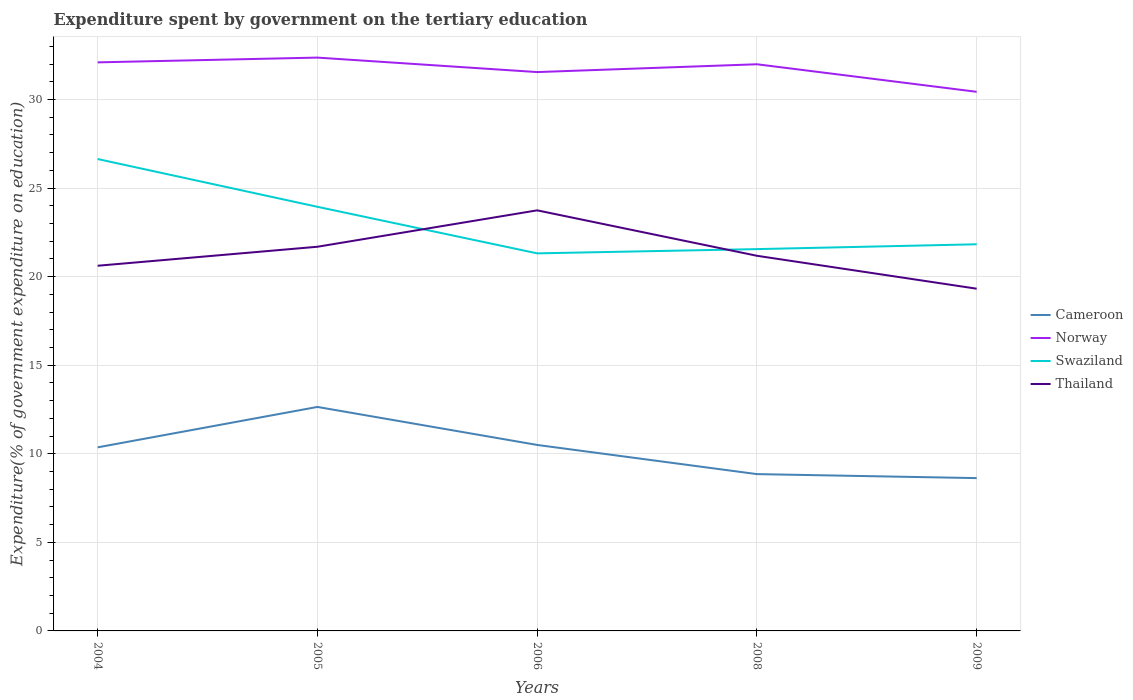Across all years, what is the maximum expenditure spent by government on the tertiary education in Norway?
Provide a succinct answer. 30.43. What is the total expenditure spent by government on the tertiary education in Cameroon in the graph?
Your answer should be compact. 3.79. What is the difference between the highest and the second highest expenditure spent by government on the tertiary education in Norway?
Offer a terse response. 1.93. What is the difference between the highest and the lowest expenditure spent by government on the tertiary education in Swaziland?
Keep it short and to the point. 2. How many lines are there?
Your answer should be very brief. 4. How many years are there in the graph?
Your answer should be very brief. 5. What is the difference between two consecutive major ticks on the Y-axis?
Your answer should be compact. 5. Are the values on the major ticks of Y-axis written in scientific E-notation?
Make the answer very short. No. How are the legend labels stacked?
Ensure brevity in your answer.  Vertical. What is the title of the graph?
Ensure brevity in your answer.  Expenditure spent by government on the tertiary education. What is the label or title of the Y-axis?
Provide a succinct answer. Expenditure(% of government expenditure on education). What is the Expenditure(% of government expenditure on education) in Cameroon in 2004?
Your response must be concise. 10.36. What is the Expenditure(% of government expenditure on education) in Norway in 2004?
Provide a short and direct response. 32.09. What is the Expenditure(% of government expenditure on education) in Swaziland in 2004?
Offer a terse response. 26.64. What is the Expenditure(% of government expenditure on education) of Thailand in 2004?
Make the answer very short. 20.61. What is the Expenditure(% of government expenditure on education) in Cameroon in 2005?
Make the answer very short. 12.64. What is the Expenditure(% of government expenditure on education) in Norway in 2005?
Your answer should be very brief. 32.36. What is the Expenditure(% of government expenditure on education) in Swaziland in 2005?
Provide a short and direct response. 23.94. What is the Expenditure(% of government expenditure on education) in Thailand in 2005?
Provide a succinct answer. 21.69. What is the Expenditure(% of government expenditure on education) in Cameroon in 2006?
Your answer should be very brief. 10.5. What is the Expenditure(% of government expenditure on education) of Norway in 2006?
Ensure brevity in your answer.  31.55. What is the Expenditure(% of government expenditure on education) of Swaziland in 2006?
Keep it short and to the point. 21.31. What is the Expenditure(% of government expenditure on education) in Thailand in 2006?
Your answer should be very brief. 23.74. What is the Expenditure(% of government expenditure on education) in Cameroon in 2008?
Provide a short and direct response. 8.85. What is the Expenditure(% of government expenditure on education) in Norway in 2008?
Provide a succinct answer. 31.99. What is the Expenditure(% of government expenditure on education) in Swaziland in 2008?
Your answer should be very brief. 21.55. What is the Expenditure(% of government expenditure on education) in Thailand in 2008?
Your response must be concise. 21.18. What is the Expenditure(% of government expenditure on education) in Cameroon in 2009?
Offer a terse response. 8.63. What is the Expenditure(% of government expenditure on education) in Norway in 2009?
Your answer should be compact. 30.43. What is the Expenditure(% of government expenditure on education) in Swaziland in 2009?
Offer a very short reply. 21.82. What is the Expenditure(% of government expenditure on education) in Thailand in 2009?
Give a very brief answer. 19.32. Across all years, what is the maximum Expenditure(% of government expenditure on education) of Cameroon?
Your answer should be compact. 12.64. Across all years, what is the maximum Expenditure(% of government expenditure on education) in Norway?
Your answer should be very brief. 32.36. Across all years, what is the maximum Expenditure(% of government expenditure on education) of Swaziland?
Your answer should be very brief. 26.64. Across all years, what is the maximum Expenditure(% of government expenditure on education) of Thailand?
Offer a very short reply. 23.74. Across all years, what is the minimum Expenditure(% of government expenditure on education) of Cameroon?
Give a very brief answer. 8.63. Across all years, what is the minimum Expenditure(% of government expenditure on education) in Norway?
Your answer should be very brief. 30.43. Across all years, what is the minimum Expenditure(% of government expenditure on education) of Swaziland?
Your answer should be very brief. 21.31. Across all years, what is the minimum Expenditure(% of government expenditure on education) of Thailand?
Your answer should be compact. 19.32. What is the total Expenditure(% of government expenditure on education) in Cameroon in the graph?
Your answer should be very brief. 50.98. What is the total Expenditure(% of government expenditure on education) in Norway in the graph?
Offer a terse response. 158.42. What is the total Expenditure(% of government expenditure on education) of Swaziland in the graph?
Your response must be concise. 115.27. What is the total Expenditure(% of government expenditure on education) in Thailand in the graph?
Provide a succinct answer. 106.53. What is the difference between the Expenditure(% of government expenditure on education) of Cameroon in 2004 and that in 2005?
Give a very brief answer. -2.28. What is the difference between the Expenditure(% of government expenditure on education) of Norway in 2004 and that in 2005?
Give a very brief answer. -0.27. What is the difference between the Expenditure(% of government expenditure on education) of Swaziland in 2004 and that in 2005?
Give a very brief answer. 2.7. What is the difference between the Expenditure(% of government expenditure on education) of Thailand in 2004 and that in 2005?
Provide a succinct answer. -1.07. What is the difference between the Expenditure(% of government expenditure on education) in Cameroon in 2004 and that in 2006?
Your answer should be very brief. -0.14. What is the difference between the Expenditure(% of government expenditure on education) in Norway in 2004 and that in 2006?
Provide a short and direct response. 0.55. What is the difference between the Expenditure(% of government expenditure on education) in Swaziland in 2004 and that in 2006?
Your response must be concise. 5.32. What is the difference between the Expenditure(% of government expenditure on education) of Thailand in 2004 and that in 2006?
Offer a terse response. -3.13. What is the difference between the Expenditure(% of government expenditure on education) of Cameroon in 2004 and that in 2008?
Give a very brief answer. 1.51. What is the difference between the Expenditure(% of government expenditure on education) of Norway in 2004 and that in 2008?
Keep it short and to the point. 0.11. What is the difference between the Expenditure(% of government expenditure on education) of Swaziland in 2004 and that in 2008?
Make the answer very short. 5.08. What is the difference between the Expenditure(% of government expenditure on education) in Thailand in 2004 and that in 2008?
Provide a succinct answer. -0.56. What is the difference between the Expenditure(% of government expenditure on education) of Cameroon in 2004 and that in 2009?
Provide a short and direct response. 1.74. What is the difference between the Expenditure(% of government expenditure on education) in Norway in 2004 and that in 2009?
Your response must be concise. 1.66. What is the difference between the Expenditure(% of government expenditure on education) in Swaziland in 2004 and that in 2009?
Offer a very short reply. 4.81. What is the difference between the Expenditure(% of government expenditure on education) of Thailand in 2004 and that in 2009?
Offer a terse response. 1.29. What is the difference between the Expenditure(% of government expenditure on education) of Cameroon in 2005 and that in 2006?
Offer a very short reply. 2.15. What is the difference between the Expenditure(% of government expenditure on education) of Norway in 2005 and that in 2006?
Your answer should be compact. 0.82. What is the difference between the Expenditure(% of government expenditure on education) in Swaziland in 2005 and that in 2006?
Make the answer very short. 2.63. What is the difference between the Expenditure(% of government expenditure on education) in Thailand in 2005 and that in 2006?
Ensure brevity in your answer.  -2.06. What is the difference between the Expenditure(% of government expenditure on education) in Cameroon in 2005 and that in 2008?
Give a very brief answer. 3.79. What is the difference between the Expenditure(% of government expenditure on education) in Norway in 2005 and that in 2008?
Give a very brief answer. 0.38. What is the difference between the Expenditure(% of government expenditure on education) of Swaziland in 2005 and that in 2008?
Offer a very short reply. 2.39. What is the difference between the Expenditure(% of government expenditure on education) of Thailand in 2005 and that in 2008?
Your answer should be very brief. 0.51. What is the difference between the Expenditure(% of government expenditure on education) of Cameroon in 2005 and that in 2009?
Your answer should be very brief. 4.02. What is the difference between the Expenditure(% of government expenditure on education) of Norway in 2005 and that in 2009?
Ensure brevity in your answer.  1.93. What is the difference between the Expenditure(% of government expenditure on education) of Swaziland in 2005 and that in 2009?
Keep it short and to the point. 2.12. What is the difference between the Expenditure(% of government expenditure on education) in Thailand in 2005 and that in 2009?
Give a very brief answer. 2.37. What is the difference between the Expenditure(% of government expenditure on education) of Cameroon in 2006 and that in 2008?
Keep it short and to the point. 1.65. What is the difference between the Expenditure(% of government expenditure on education) in Norway in 2006 and that in 2008?
Ensure brevity in your answer.  -0.44. What is the difference between the Expenditure(% of government expenditure on education) of Swaziland in 2006 and that in 2008?
Ensure brevity in your answer.  -0.24. What is the difference between the Expenditure(% of government expenditure on education) in Thailand in 2006 and that in 2008?
Your response must be concise. 2.56. What is the difference between the Expenditure(% of government expenditure on education) in Cameroon in 2006 and that in 2009?
Keep it short and to the point. 1.87. What is the difference between the Expenditure(% of government expenditure on education) in Norway in 2006 and that in 2009?
Offer a very short reply. 1.11. What is the difference between the Expenditure(% of government expenditure on education) in Swaziland in 2006 and that in 2009?
Keep it short and to the point. -0.51. What is the difference between the Expenditure(% of government expenditure on education) in Thailand in 2006 and that in 2009?
Ensure brevity in your answer.  4.42. What is the difference between the Expenditure(% of government expenditure on education) in Cameroon in 2008 and that in 2009?
Make the answer very short. 0.23. What is the difference between the Expenditure(% of government expenditure on education) of Norway in 2008 and that in 2009?
Your response must be concise. 1.56. What is the difference between the Expenditure(% of government expenditure on education) in Swaziland in 2008 and that in 2009?
Keep it short and to the point. -0.27. What is the difference between the Expenditure(% of government expenditure on education) in Thailand in 2008 and that in 2009?
Offer a terse response. 1.86. What is the difference between the Expenditure(% of government expenditure on education) in Cameroon in 2004 and the Expenditure(% of government expenditure on education) in Norway in 2005?
Offer a terse response. -22. What is the difference between the Expenditure(% of government expenditure on education) of Cameroon in 2004 and the Expenditure(% of government expenditure on education) of Swaziland in 2005?
Provide a succinct answer. -13.58. What is the difference between the Expenditure(% of government expenditure on education) in Cameroon in 2004 and the Expenditure(% of government expenditure on education) in Thailand in 2005?
Offer a terse response. -11.32. What is the difference between the Expenditure(% of government expenditure on education) of Norway in 2004 and the Expenditure(% of government expenditure on education) of Swaziland in 2005?
Provide a succinct answer. 8.15. What is the difference between the Expenditure(% of government expenditure on education) of Norway in 2004 and the Expenditure(% of government expenditure on education) of Thailand in 2005?
Your response must be concise. 10.41. What is the difference between the Expenditure(% of government expenditure on education) of Swaziland in 2004 and the Expenditure(% of government expenditure on education) of Thailand in 2005?
Make the answer very short. 4.95. What is the difference between the Expenditure(% of government expenditure on education) in Cameroon in 2004 and the Expenditure(% of government expenditure on education) in Norway in 2006?
Provide a succinct answer. -21.18. What is the difference between the Expenditure(% of government expenditure on education) of Cameroon in 2004 and the Expenditure(% of government expenditure on education) of Swaziland in 2006?
Ensure brevity in your answer.  -10.95. What is the difference between the Expenditure(% of government expenditure on education) in Cameroon in 2004 and the Expenditure(% of government expenditure on education) in Thailand in 2006?
Make the answer very short. -13.38. What is the difference between the Expenditure(% of government expenditure on education) of Norway in 2004 and the Expenditure(% of government expenditure on education) of Swaziland in 2006?
Make the answer very short. 10.78. What is the difference between the Expenditure(% of government expenditure on education) of Norway in 2004 and the Expenditure(% of government expenditure on education) of Thailand in 2006?
Make the answer very short. 8.35. What is the difference between the Expenditure(% of government expenditure on education) of Swaziland in 2004 and the Expenditure(% of government expenditure on education) of Thailand in 2006?
Provide a succinct answer. 2.9. What is the difference between the Expenditure(% of government expenditure on education) in Cameroon in 2004 and the Expenditure(% of government expenditure on education) in Norway in 2008?
Give a very brief answer. -21.62. What is the difference between the Expenditure(% of government expenditure on education) in Cameroon in 2004 and the Expenditure(% of government expenditure on education) in Swaziland in 2008?
Provide a short and direct response. -11.19. What is the difference between the Expenditure(% of government expenditure on education) of Cameroon in 2004 and the Expenditure(% of government expenditure on education) of Thailand in 2008?
Your response must be concise. -10.81. What is the difference between the Expenditure(% of government expenditure on education) of Norway in 2004 and the Expenditure(% of government expenditure on education) of Swaziland in 2008?
Your answer should be compact. 10.54. What is the difference between the Expenditure(% of government expenditure on education) in Norway in 2004 and the Expenditure(% of government expenditure on education) in Thailand in 2008?
Offer a terse response. 10.92. What is the difference between the Expenditure(% of government expenditure on education) in Swaziland in 2004 and the Expenditure(% of government expenditure on education) in Thailand in 2008?
Ensure brevity in your answer.  5.46. What is the difference between the Expenditure(% of government expenditure on education) in Cameroon in 2004 and the Expenditure(% of government expenditure on education) in Norway in 2009?
Provide a short and direct response. -20.07. What is the difference between the Expenditure(% of government expenditure on education) of Cameroon in 2004 and the Expenditure(% of government expenditure on education) of Swaziland in 2009?
Keep it short and to the point. -11.46. What is the difference between the Expenditure(% of government expenditure on education) in Cameroon in 2004 and the Expenditure(% of government expenditure on education) in Thailand in 2009?
Keep it short and to the point. -8.96. What is the difference between the Expenditure(% of government expenditure on education) of Norway in 2004 and the Expenditure(% of government expenditure on education) of Swaziland in 2009?
Give a very brief answer. 10.27. What is the difference between the Expenditure(% of government expenditure on education) of Norway in 2004 and the Expenditure(% of government expenditure on education) of Thailand in 2009?
Ensure brevity in your answer.  12.78. What is the difference between the Expenditure(% of government expenditure on education) in Swaziland in 2004 and the Expenditure(% of government expenditure on education) in Thailand in 2009?
Provide a short and direct response. 7.32. What is the difference between the Expenditure(% of government expenditure on education) in Cameroon in 2005 and the Expenditure(% of government expenditure on education) in Norway in 2006?
Provide a short and direct response. -18.9. What is the difference between the Expenditure(% of government expenditure on education) of Cameroon in 2005 and the Expenditure(% of government expenditure on education) of Swaziland in 2006?
Your answer should be compact. -8.67. What is the difference between the Expenditure(% of government expenditure on education) of Cameroon in 2005 and the Expenditure(% of government expenditure on education) of Thailand in 2006?
Your answer should be compact. -11.1. What is the difference between the Expenditure(% of government expenditure on education) of Norway in 2005 and the Expenditure(% of government expenditure on education) of Swaziland in 2006?
Keep it short and to the point. 11.05. What is the difference between the Expenditure(% of government expenditure on education) in Norway in 2005 and the Expenditure(% of government expenditure on education) in Thailand in 2006?
Give a very brief answer. 8.62. What is the difference between the Expenditure(% of government expenditure on education) of Swaziland in 2005 and the Expenditure(% of government expenditure on education) of Thailand in 2006?
Your answer should be compact. 0.2. What is the difference between the Expenditure(% of government expenditure on education) in Cameroon in 2005 and the Expenditure(% of government expenditure on education) in Norway in 2008?
Provide a succinct answer. -19.34. What is the difference between the Expenditure(% of government expenditure on education) in Cameroon in 2005 and the Expenditure(% of government expenditure on education) in Swaziland in 2008?
Your answer should be very brief. -8.91. What is the difference between the Expenditure(% of government expenditure on education) of Cameroon in 2005 and the Expenditure(% of government expenditure on education) of Thailand in 2008?
Ensure brevity in your answer.  -8.53. What is the difference between the Expenditure(% of government expenditure on education) of Norway in 2005 and the Expenditure(% of government expenditure on education) of Swaziland in 2008?
Your answer should be compact. 10.81. What is the difference between the Expenditure(% of government expenditure on education) in Norway in 2005 and the Expenditure(% of government expenditure on education) in Thailand in 2008?
Ensure brevity in your answer.  11.19. What is the difference between the Expenditure(% of government expenditure on education) of Swaziland in 2005 and the Expenditure(% of government expenditure on education) of Thailand in 2008?
Your answer should be very brief. 2.76. What is the difference between the Expenditure(% of government expenditure on education) in Cameroon in 2005 and the Expenditure(% of government expenditure on education) in Norway in 2009?
Provide a succinct answer. -17.79. What is the difference between the Expenditure(% of government expenditure on education) of Cameroon in 2005 and the Expenditure(% of government expenditure on education) of Swaziland in 2009?
Make the answer very short. -9.18. What is the difference between the Expenditure(% of government expenditure on education) in Cameroon in 2005 and the Expenditure(% of government expenditure on education) in Thailand in 2009?
Keep it short and to the point. -6.67. What is the difference between the Expenditure(% of government expenditure on education) in Norway in 2005 and the Expenditure(% of government expenditure on education) in Swaziland in 2009?
Give a very brief answer. 10.54. What is the difference between the Expenditure(% of government expenditure on education) of Norway in 2005 and the Expenditure(% of government expenditure on education) of Thailand in 2009?
Offer a terse response. 13.04. What is the difference between the Expenditure(% of government expenditure on education) of Swaziland in 2005 and the Expenditure(% of government expenditure on education) of Thailand in 2009?
Your response must be concise. 4.62. What is the difference between the Expenditure(% of government expenditure on education) in Cameroon in 2006 and the Expenditure(% of government expenditure on education) in Norway in 2008?
Provide a short and direct response. -21.49. What is the difference between the Expenditure(% of government expenditure on education) in Cameroon in 2006 and the Expenditure(% of government expenditure on education) in Swaziland in 2008?
Ensure brevity in your answer.  -11.05. What is the difference between the Expenditure(% of government expenditure on education) of Cameroon in 2006 and the Expenditure(% of government expenditure on education) of Thailand in 2008?
Make the answer very short. -10.68. What is the difference between the Expenditure(% of government expenditure on education) in Norway in 2006 and the Expenditure(% of government expenditure on education) in Swaziland in 2008?
Ensure brevity in your answer.  9.99. What is the difference between the Expenditure(% of government expenditure on education) in Norway in 2006 and the Expenditure(% of government expenditure on education) in Thailand in 2008?
Offer a very short reply. 10.37. What is the difference between the Expenditure(% of government expenditure on education) of Swaziland in 2006 and the Expenditure(% of government expenditure on education) of Thailand in 2008?
Give a very brief answer. 0.14. What is the difference between the Expenditure(% of government expenditure on education) of Cameroon in 2006 and the Expenditure(% of government expenditure on education) of Norway in 2009?
Make the answer very short. -19.93. What is the difference between the Expenditure(% of government expenditure on education) of Cameroon in 2006 and the Expenditure(% of government expenditure on education) of Swaziland in 2009?
Keep it short and to the point. -11.33. What is the difference between the Expenditure(% of government expenditure on education) in Cameroon in 2006 and the Expenditure(% of government expenditure on education) in Thailand in 2009?
Provide a succinct answer. -8.82. What is the difference between the Expenditure(% of government expenditure on education) of Norway in 2006 and the Expenditure(% of government expenditure on education) of Swaziland in 2009?
Give a very brief answer. 9.72. What is the difference between the Expenditure(% of government expenditure on education) of Norway in 2006 and the Expenditure(% of government expenditure on education) of Thailand in 2009?
Your response must be concise. 12.23. What is the difference between the Expenditure(% of government expenditure on education) in Swaziland in 2006 and the Expenditure(% of government expenditure on education) in Thailand in 2009?
Offer a very short reply. 1.99. What is the difference between the Expenditure(% of government expenditure on education) of Cameroon in 2008 and the Expenditure(% of government expenditure on education) of Norway in 2009?
Ensure brevity in your answer.  -21.58. What is the difference between the Expenditure(% of government expenditure on education) of Cameroon in 2008 and the Expenditure(% of government expenditure on education) of Swaziland in 2009?
Provide a short and direct response. -12.97. What is the difference between the Expenditure(% of government expenditure on education) of Cameroon in 2008 and the Expenditure(% of government expenditure on education) of Thailand in 2009?
Keep it short and to the point. -10.47. What is the difference between the Expenditure(% of government expenditure on education) in Norway in 2008 and the Expenditure(% of government expenditure on education) in Swaziland in 2009?
Keep it short and to the point. 10.16. What is the difference between the Expenditure(% of government expenditure on education) in Norway in 2008 and the Expenditure(% of government expenditure on education) in Thailand in 2009?
Give a very brief answer. 12.67. What is the difference between the Expenditure(% of government expenditure on education) in Swaziland in 2008 and the Expenditure(% of government expenditure on education) in Thailand in 2009?
Offer a very short reply. 2.23. What is the average Expenditure(% of government expenditure on education) in Cameroon per year?
Provide a short and direct response. 10.2. What is the average Expenditure(% of government expenditure on education) in Norway per year?
Your answer should be very brief. 31.68. What is the average Expenditure(% of government expenditure on education) of Swaziland per year?
Your answer should be compact. 23.05. What is the average Expenditure(% of government expenditure on education) in Thailand per year?
Your response must be concise. 21.31. In the year 2004, what is the difference between the Expenditure(% of government expenditure on education) in Cameroon and Expenditure(% of government expenditure on education) in Norway?
Give a very brief answer. -21.73. In the year 2004, what is the difference between the Expenditure(% of government expenditure on education) of Cameroon and Expenditure(% of government expenditure on education) of Swaziland?
Your answer should be compact. -16.27. In the year 2004, what is the difference between the Expenditure(% of government expenditure on education) of Cameroon and Expenditure(% of government expenditure on education) of Thailand?
Your answer should be compact. -10.25. In the year 2004, what is the difference between the Expenditure(% of government expenditure on education) of Norway and Expenditure(% of government expenditure on education) of Swaziland?
Provide a succinct answer. 5.46. In the year 2004, what is the difference between the Expenditure(% of government expenditure on education) of Norway and Expenditure(% of government expenditure on education) of Thailand?
Give a very brief answer. 11.48. In the year 2004, what is the difference between the Expenditure(% of government expenditure on education) in Swaziland and Expenditure(% of government expenditure on education) in Thailand?
Your answer should be very brief. 6.02. In the year 2005, what is the difference between the Expenditure(% of government expenditure on education) of Cameroon and Expenditure(% of government expenditure on education) of Norway?
Make the answer very short. -19.72. In the year 2005, what is the difference between the Expenditure(% of government expenditure on education) in Cameroon and Expenditure(% of government expenditure on education) in Swaziland?
Offer a very short reply. -11.3. In the year 2005, what is the difference between the Expenditure(% of government expenditure on education) of Cameroon and Expenditure(% of government expenditure on education) of Thailand?
Your response must be concise. -9.04. In the year 2005, what is the difference between the Expenditure(% of government expenditure on education) of Norway and Expenditure(% of government expenditure on education) of Swaziland?
Your answer should be very brief. 8.42. In the year 2005, what is the difference between the Expenditure(% of government expenditure on education) in Norway and Expenditure(% of government expenditure on education) in Thailand?
Make the answer very short. 10.68. In the year 2005, what is the difference between the Expenditure(% of government expenditure on education) of Swaziland and Expenditure(% of government expenditure on education) of Thailand?
Your response must be concise. 2.25. In the year 2006, what is the difference between the Expenditure(% of government expenditure on education) of Cameroon and Expenditure(% of government expenditure on education) of Norway?
Offer a terse response. -21.05. In the year 2006, what is the difference between the Expenditure(% of government expenditure on education) in Cameroon and Expenditure(% of government expenditure on education) in Swaziland?
Make the answer very short. -10.81. In the year 2006, what is the difference between the Expenditure(% of government expenditure on education) in Cameroon and Expenditure(% of government expenditure on education) in Thailand?
Provide a short and direct response. -13.24. In the year 2006, what is the difference between the Expenditure(% of government expenditure on education) of Norway and Expenditure(% of government expenditure on education) of Swaziland?
Provide a short and direct response. 10.23. In the year 2006, what is the difference between the Expenditure(% of government expenditure on education) of Norway and Expenditure(% of government expenditure on education) of Thailand?
Offer a terse response. 7.8. In the year 2006, what is the difference between the Expenditure(% of government expenditure on education) in Swaziland and Expenditure(% of government expenditure on education) in Thailand?
Provide a short and direct response. -2.43. In the year 2008, what is the difference between the Expenditure(% of government expenditure on education) of Cameroon and Expenditure(% of government expenditure on education) of Norway?
Your answer should be very brief. -23.14. In the year 2008, what is the difference between the Expenditure(% of government expenditure on education) in Cameroon and Expenditure(% of government expenditure on education) in Swaziland?
Your answer should be very brief. -12.7. In the year 2008, what is the difference between the Expenditure(% of government expenditure on education) of Cameroon and Expenditure(% of government expenditure on education) of Thailand?
Give a very brief answer. -12.32. In the year 2008, what is the difference between the Expenditure(% of government expenditure on education) in Norway and Expenditure(% of government expenditure on education) in Swaziland?
Keep it short and to the point. 10.43. In the year 2008, what is the difference between the Expenditure(% of government expenditure on education) in Norway and Expenditure(% of government expenditure on education) in Thailand?
Provide a succinct answer. 10.81. In the year 2008, what is the difference between the Expenditure(% of government expenditure on education) of Swaziland and Expenditure(% of government expenditure on education) of Thailand?
Offer a very short reply. 0.38. In the year 2009, what is the difference between the Expenditure(% of government expenditure on education) in Cameroon and Expenditure(% of government expenditure on education) in Norway?
Provide a succinct answer. -21.81. In the year 2009, what is the difference between the Expenditure(% of government expenditure on education) in Cameroon and Expenditure(% of government expenditure on education) in Swaziland?
Give a very brief answer. -13.2. In the year 2009, what is the difference between the Expenditure(% of government expenditure on education) in Cameroon and Expenditure(% of government expenditure on education) in Thailand?
Offer a very short reply. -10.69. In the year 2009, what is the difference between the Expenditure(% of government expenditure on education) of Norway and Expenditure(% of government expenditure on education) of Swaziland?
Your response must be concise. 8.61. In the year 2009, what is the difference between the Expenditure(% of government expenditure on education) of Norway and Expenditure(% of government expenditure on education) of Thailand?
Your response must be concise. 11.11. In the year 2009, what is the difference between the Expenditure(% of government expenditure on education) in Swaziland and Expenditure(% of government expenditure on education) in Thailand?
Give a very brief answer. 2.51. What is the ratio of the Expenditure(% of government expenditure on education) of Cameroon in 2004 to that in 2005?
Offer a terse response. 0.82. What is the ratio of the Expenditure(% of government expenditure on education) in Norway in 2004 to that in 2005?
Your response must be concise. 0.99. What is the ratio of the Expenditure(% of government expenditure on education) in Swaziland in 2004 to that in 2005?
Offer a terse response. 1.11. What is the ratio of the Expenditure(% of government expenditure on education) of Thailand in 2004 to that in 2005?
Offer a terse response. 0.95. What is the ratio of the Expenditure(% of government expenditure on education) in Cameroon in 2004 to that in 2006?
Make the answer very short. 0.99. What is the ratio of the Expenditure(% of government expenditure on education) in Norway in 2004 to that in 2006?
Give a very brief answer. 1.02. What is the ratio of the Expenditure(% of government expenditure on education) of Swaziland in 2004 to that in 2006?
Ensure brevity in your answer.  1.25. What is the ratio of the Expenditure(% of government expenditure on education) in Thailand in 2004 to that in 2006?
Keep it short and to the point. 0.87. What is the ratio of the Expenditure(% of government expenditure on education) in Cameroon in 2004 to that in 2008?
Your answer should be very brief. 1.17. What is the ratio of the Expenditure(% of government expenditure on education) of Swaziland in 2004 to that in 2008?
Offer a terse response. 1.24. What is the ratio of the Expenditure(% of government expenditure on education) of Thailand in 2004 to that in 2008?
Offer a very short reply. 0.97. What is the ratio of the Expenditure(% of government expenditure on education) of Cameroon in 2004 to that in 2009?
Your answer should be compact. 1.2. What is the ratio of the Expenditure(% of government expenditure on education) of Norway in 2004 to that in 2009?
Provide a short and direct response. 1.05. What is the ratio of the Expenditure(% of government expenditure on education) of Swaziland in 2004 to that in 2009?
Offer a very short reply. 1.22. What is the ratio of the Expenditure(% of government expenditure on education) in Thailand in 2004 to that in 2009?
Your response must be concise. 1.07. What is the ratio of the Expenditure(% of government expenditure on education) of Cameroon in 2005 to that in 2006?
Keep it short and to the point. 1.2. What is the ratio of the Expenditure(% of government expenditure on education) of Norway in 2005 to that in 2006?
Your answer should be compact. 1.03. What is the ratio of the Expenditure(% of government expenditure on education) of Swaziland in 2005 to that in 2006?
Your answer should be compact. 1.12. What is the ratio of the Expenditure(% of government expenditure on education) of Thailand in 2005 to that in 2006?
Your answer should be very brief. 0.91. What is the ratio of the Expenditure(% of government expenditure on education) in Cameroon in 2005 to that in 2008?
Give a very brief answer. 1.43. What is the ratio of the Expenditure(% of government expenditure on education) of Norway in 2005 to that in 2008?
Your answer should be compact. 1.01. What is the ratio of the Expenditure(% of government expenditure on education) in Swaziland in 2005 to that in 2008?
Give a very brief answer. 1.11. What is the ratio of the Expenditure(% of government expenditure on education) in Thailand in 2005 to that in 2008?
Your response must be concise. 1.02. What is the ratio of the Expenditure(% of government expenditure on education) of Cameroon in 2005 to that in 2009?
Keep it short and to the point. 1.47. What is the ratio of the Expenditure(% of government expenditure on education) in Norway in 2005 to that in 2009?
Give a very brief answer. 1.06. What is the ratio of the Expenditure(% of government expenditure on education) of Swaziland in 2005 to that in 2009?
Ensure brevity in your answer.  1.1. What is the ratio of the Expenditure(% of government expenditure on education) of Thailand in 2005 to that in 2009?
Make the answer very short. 1.12. What is the ratio of the Expenditure(% of government expenditure on education) in Cameroon in 2006 to that in 2008?
Your response must be concise. 1.19. What is the ratio of the Expenditure(% of government expenditure on education) in Norway in 2006 to that in 2008?
Your answer should be very brief. 0.99. What is the ratio of the Expenditure(% of government expenditure on education) of Swaziland in 2006 to that in 2008?
Give a very brief answer. 0.99. What is the ratio of the Expenditure(% of government expenditure on education) in Thailand in 2006 to that in 2008?
Give a very brief answer. 1.12. What is the ratio of the Expenditure(% of government expenditure on education) of Cameroon in 2006 to that in 2009?
Your response must be concise. 1.22. What is the ratio of the Expenditure(% of government expenditure on education) in Norway in 2006 to that in 2009?
Ensure brevity in your answer.  1.04. What is the ratio of the Expenditure(% of government expenditure on education) in Swaziland in 2006 to that in 2009?
Ensure brevity in your answer.  0.98. What is the ratio of the Expenditure(% of government expenditure on education) in Thailand in 2006 to that in 2009?
Your answer should be compact. 1.23. What is the ratio of the Expenditure(% of government expenditure on education) of Cameroon in 2008 to that in 2009?
Provide a short and direct response. 1.03. What is the ratio of the Expenditure(% of government expenditure on education) of Norway in 2008 to that in 2009?
Provide a succinct answer. 1.05. What is the ratio of the Expenditure(% of government expenditure on education) in Swaziland in 2008 to that in 2009?
Provide a short and direct response. 0.99. What is the ratio of the Expenditure(% of government expenditure on education) of Thailand in 2008 to that in 2009?
Make the answer very short. 1.1. What is the difference between the highest and the second highest Expenditure(% of government expenditure on education) of Cameroon?
Provide a succinct answer. 2.15. What is the difference between the highest and the second highest Expenditure(% of government expenditure on education) in Norway?
Provide a succinct answer. 0.27. What is the difference between the highest and the second highest Expenditure(% of government expenditure on education) of Swaziland?
Provide a short and direct response. 2.7. What is the difference between the highest and the second highest Expenditure(% of government expenditure on education) in Thailand?
Your answer should be compact. 2.06. What is the difference between the highest and the lowest Expenditure(% of government expenditure on education) in Cameroon?
Ensure brevity in your answer.  4.02. What is the difference between the highest and the lowest Expenditure(% of government expenditure on education) in Norway?
Your answer should be very brief. 1.93. What is the difference between the highest and the lowest Expenditure(% of government expenditure on education) of Swaziland?
Keep it short and to the point. 5.32. What is the difference between the highest and the lowest Expenditure(% of government expenditure on education) in Thailand?
Your answer should be compact. 4.42. 